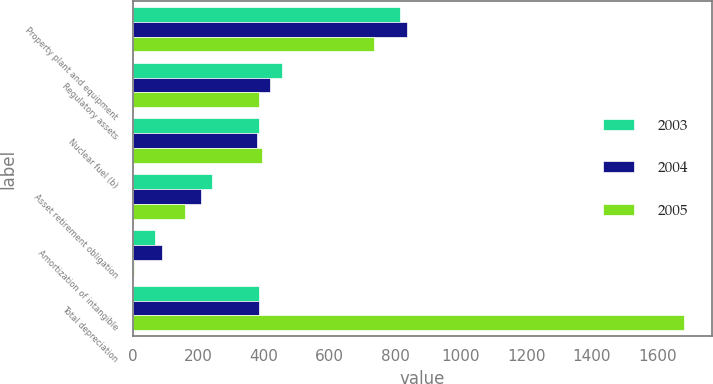Convert chart to OTSL. <chart><loc_0><loc_0><loc_500><loc_500><stacked_bar_chart><ecel><fcel>Property plant and equipment<fcel>Regulatory assets<fcel>Nuclear fuel (b)<fcel>Asset retirement obligation<fcel>Amortization of intangible<fcel>Total depreciation<nl><fcel>2003<fcel>816<fcel>454<fcel>385<fcel>243<fcel>69<fcel>385.5<nl><fcel>2004<fcel>835<fcel>418<fcel>380<fcel>210<fcel>90<fcel>385.5<nl><fcel>2005<fcel>736<fcel>386<fcel>395<fcel>160<fcel>4<fcel>1681<nl></chart> 